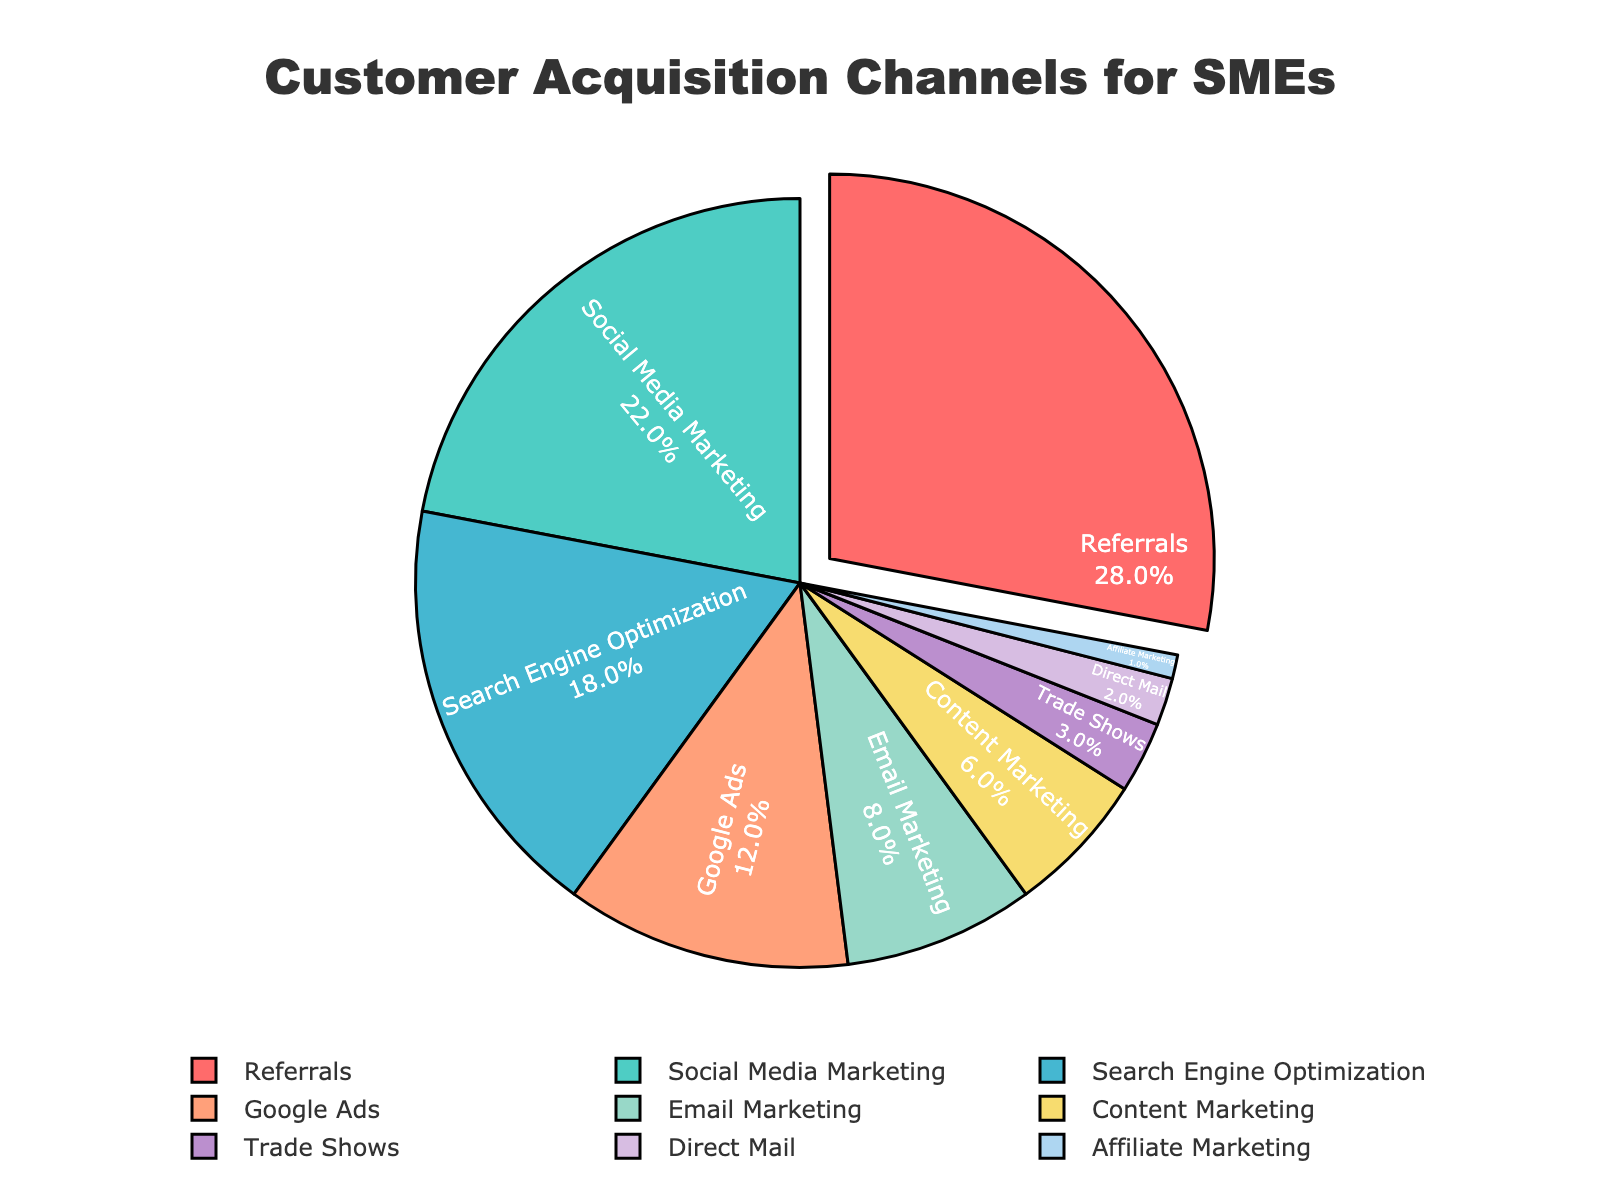What's the largest customer acquisition channel for SMEs in the figure? The largest segment is identified by looking at the segment that has been pulled out from the pie chart, which is labeled "Referrals" with 28%.
Answer: Referrals Which channels collectively account for more than 50% of the customer acquisition? To find this, we need to sum the percentages of the largest channels until the total exceeds 50%. Referrals (28%) + Social Media Marketing (22%) = 50%.
Answer: Referrals and Social Media Marketing How much more effective is Search Engine Optimization compared to Google Ads? The percent value for Search Engine Optimization is 18% and for Google Ads is 12%. To find the difference, subtract Google Ads from Search Engine Optimization (18% - 12% = 6%).
Answer: 6% What percentage of customer acquisition is made up of channels other than Referrals, Social Media Marketing, and Search Engine Optimization combined? Calculate the combined percentage of the three channels first: Referrals (28%) + Social Media Marketing (22%) + Search Engine Optimization (18%) = 68%. Then subtract this from 100% (100% - 68% = 32%).
Answer: 32% Which channels are responsible for the smallest share of customer acquisition and what is their combined percentage? The smallest shares are Direct Mail (2%) and Affiliate Marketing (1%). Their combined percentage is (2% + 1% = 3%).
Answer: Direct Mail and Affiliate Marketing, 3% What is the total percentage of customer acquisition accounted for by channels related to online marketing? Sum the percentages of channels that can be classified as online marketing: Social Media Marketing (22%), Search Engine Optimization (18%), Google Ads (12%), Email Marketing (8%), Content Marketing (6%), and Affiliate Marketing (1%). So, 22% + 18% + 12% + 8% + 6% + 1% = 67%.
Answer: 67% By how much does Email Marketing lead Content Marketing in customer acquisition percentage? Look at their respective percentages, Email Marketing (8%) and Content Marketing (6%), then subtract the smaller from the larger (8% - 6% = 2%).
Answer: 2% What is the difference in combined percentage between Trade Shows and Direct Mail compared to the leading channel? First sum the percentages for Trade Shows (3%) and Direct Mail (2%) to get 5%. Then calculate the difference between this sum and the percentage for Referrals (28%) (28% - 5% = 23%).
Answer: 23% How many channels contribute more than 10% to customer acquisition according to the figure? Identify and count the channels with percentages greater than 10%: Referrals (28%), Social Media Marketing (22%), Search Engine Optimization (18%), and Google Ads (12%). There are 4 such channels.
Answer: 4 